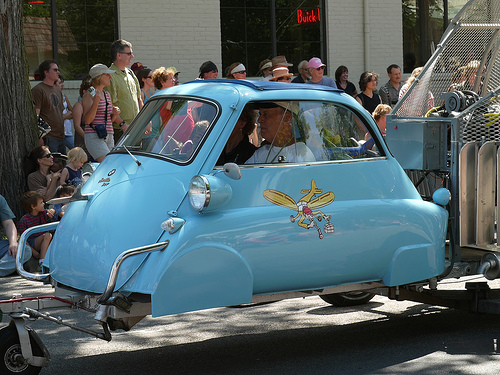<image>
Is there a man to the left of the woman? Yes. From this viewpoint, the man is positioned to the left side relative to the woman. Where is the window in relation to the decal? Is it above the decal? Yes. The window is positioned above the decal in the vertical space, higher up in the scene. 